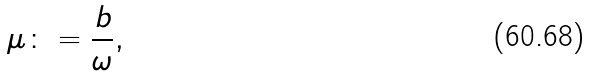Convert formula to latex. <formula><loc_0><loc_0><loc_500><loc_500>\mu \colon = \frac { b } { \omega } ,</formula> 